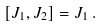Convert formula to latex. <formula><loc_0><loc_0><loc_500><loc_500>[ J _ { 1 } , J _ { 2 } ] = J _ { 1 } \, .</formula> 